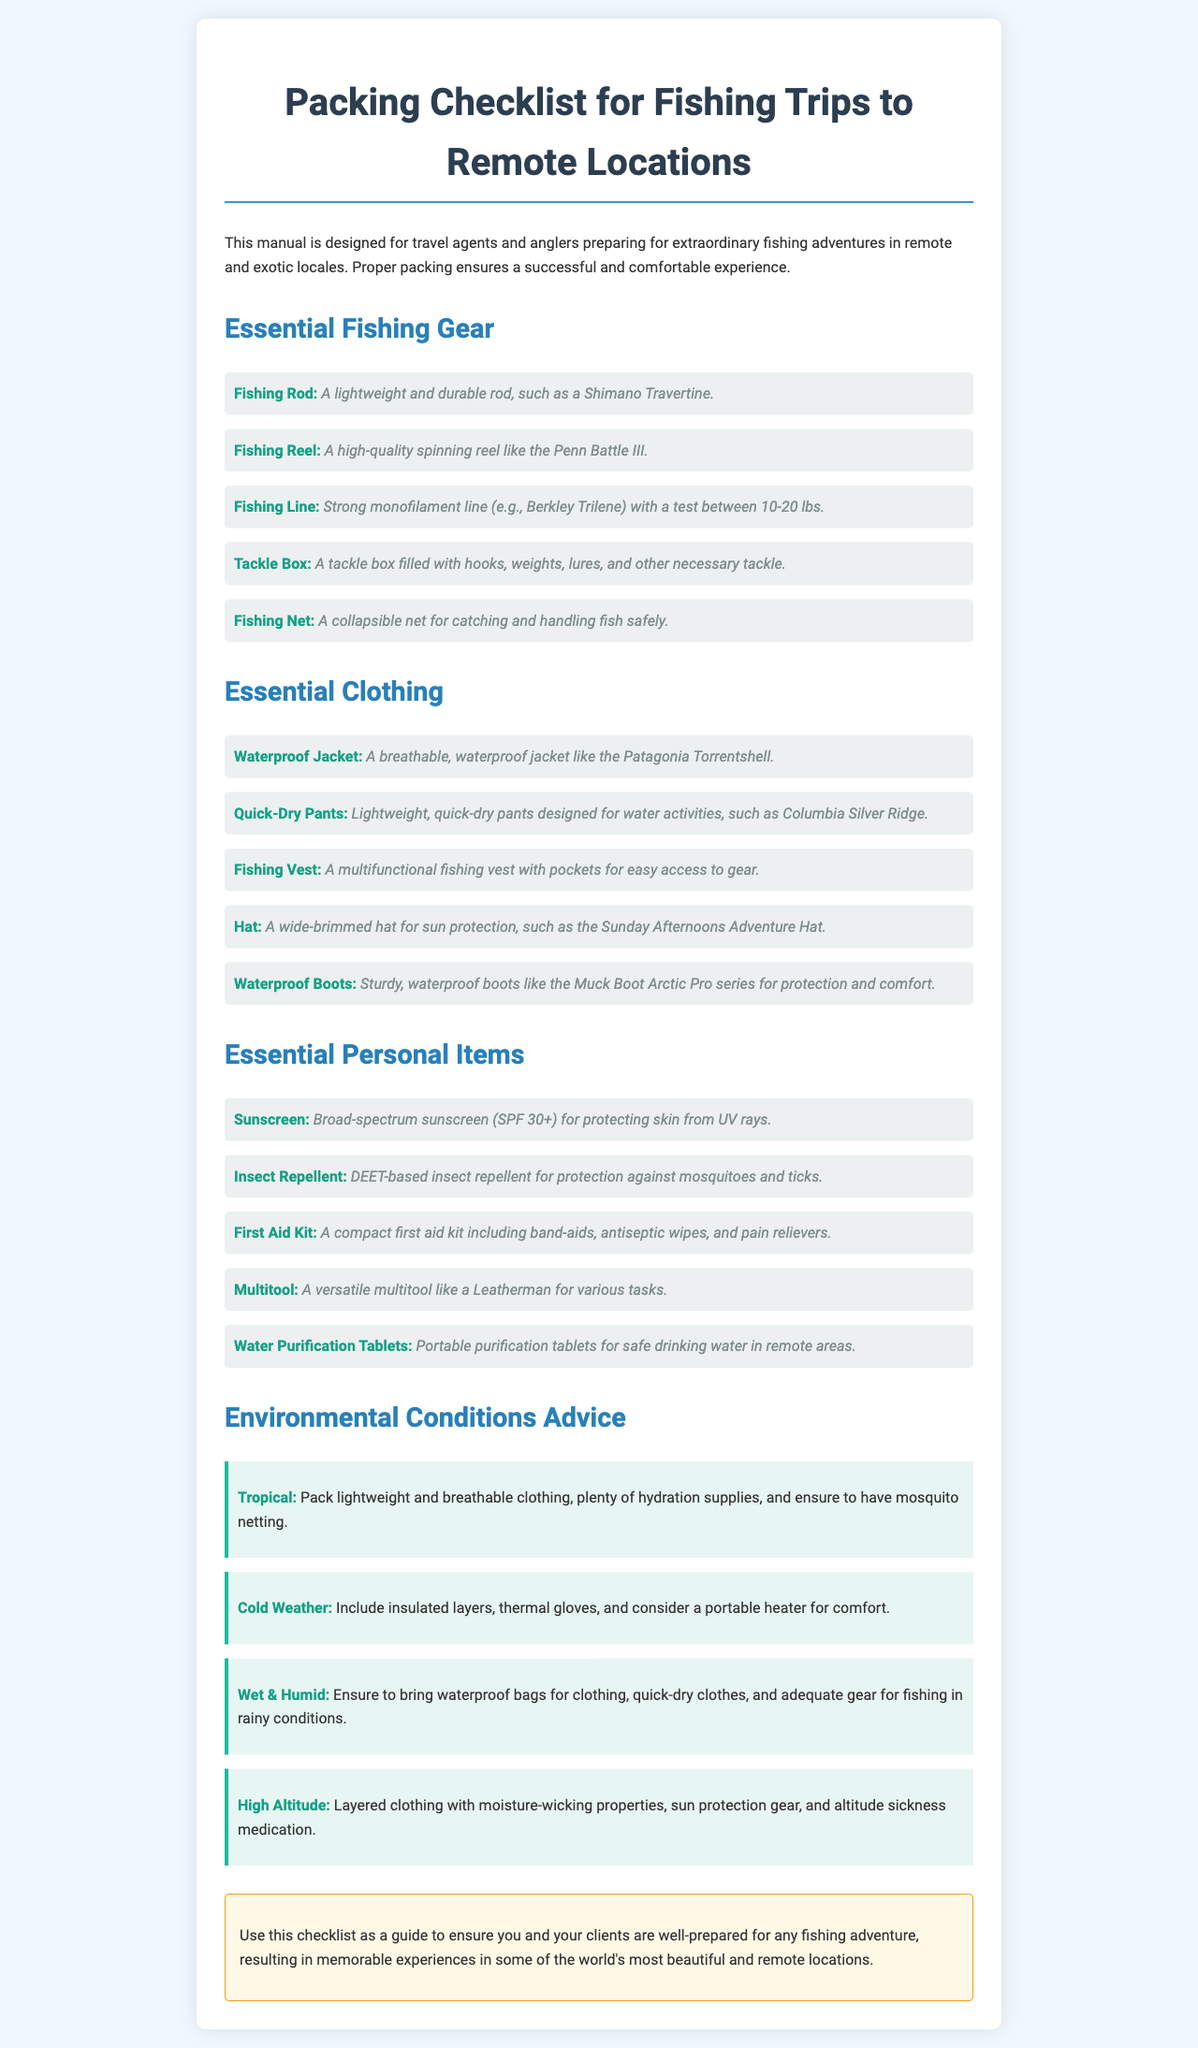what is the title of the manual? The title of the manual is found at the top of the document, which provides clarity about its content.
Answer: Packing Checklist for Fishing Trips to Remote Locations how many essential clothing items are listed? The document provides a specific number of clothing items under the clothing section.
Answer: 5 which fishing reel is recommended? The recommended fishing reel is identified in the essential fishing gear section for its quality and reliability.
Answer: Penn Battle III what should you pack for wet and humid conditions? The document outlines specific items needed for different environmental conditions, including this one.
Answer: Waterproof bags what is one item included in the Essential Personal Items section? The document lists various personal items that are essential for fishing, allowing for easy retrieval of specific names.
Answer: Sunscreen which environmental condition suggests packing insulated layers? The document provides a clear association between environmental conditions and recommended packing items.
Answer: Cold Weather what type of insect repellent is recommended? The specific type of insect repellent recommended is noted in the Personal Items section for effectiveness.
Answer: DEET-based what is a necessary item for high altitude conditions? The document mentions this item as part of the advice for conditions at high altitudes to ensure safety.
Answer: Altitude sickness medication 